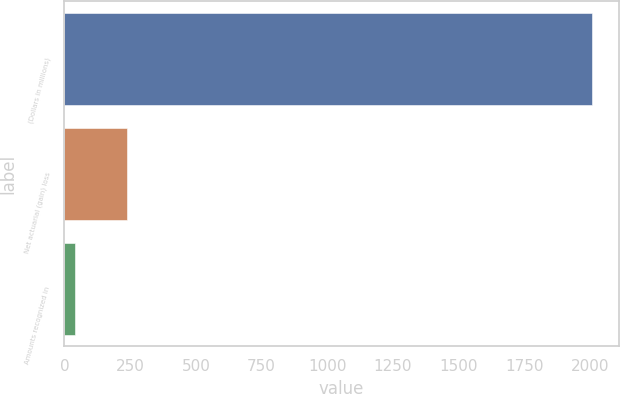Convert chart. <chart><loc_0><loc_0><loc_500><loc_500><bar_chart><fcel>(Dollars in millions)<fcel>Net actuarial (gain) loss<fcel>Amounts recognized in<nl><fcel>2008<fcel>236.8<fcel>40<nl></chart> 